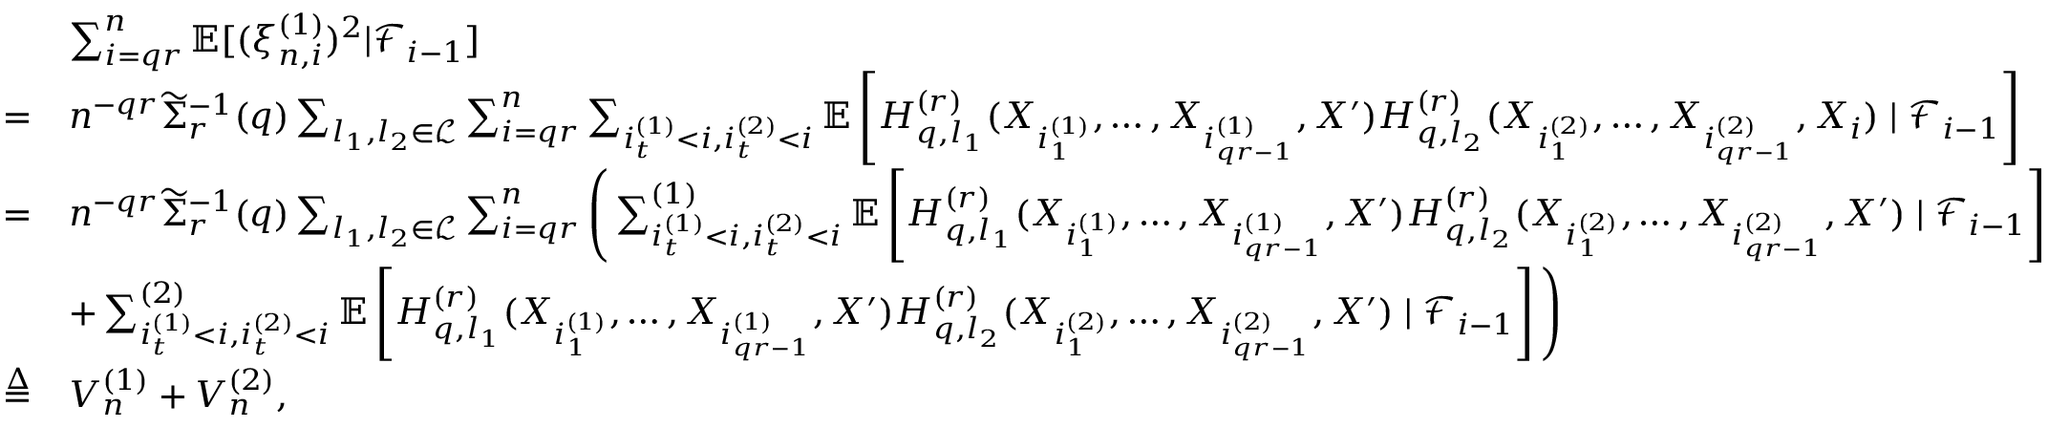<formula> <loc_0><loc_0><loc_500><loc_500>\begin{array} { r l } & { \sum _ { i = q r } ^ { n } \mathbb { E } [ ( \xi _ { n , i } ^ { ( 1 ) } ) ^ { 2 } | \mathcal { F } _ { i - 1 } ] } \\ { = } & { n ^ { - q r } \widetilde { \Sigma } _ { r } ^ { - 1 } ( q ) \sum _ { l _ { 1 } , l _ { 2 } \in \mathcal { L } } \sum _ { i = q r } ^ { n } \sum _ { i _ { t } ^ { ( 1 ) } < i , i _ { t } ^ { ( 2 ) } < i } \mathbb { E } \left [ H _ { q , l _ { 1 } } ^ { ( r ) } ( X _ { i _ { 1 } ^ { ( 1 ) } } , \dots , X _ { i _ { q r - 1 } ^ { ( 1 ) } } , X ^ { \prime } ) H _ { q , l _ { 2 } } ^ { ( r ) } ( X _ { i _ { 1 } ^ { ( 2 ) } } , \dots , X _ { i _ { q r - 1 } ^ { ( 2 ) } } , X _ { i } ) | \mathcal { F } _ { i - 1 } \right ] } \\ { = } & { n ^ { - q r } \widetilde { \Sigma } _ { r } ^ { - 1 } ( q ) \sum _ { l _ { 1 } , l _ { 2 } \in \mathcal { L } } \sum _ { i = q r } ^ { n } \left ( \sum _ { i _ { t } ^ { ( 1 ) } < i , i _ { t } ^ { ( 2 ) } < i } ^ { ( 1 ) } \mathbb { E } \left [ H _ { q , l _ { 1 } } ^ { ( r ) } ( X _ { i _ { 1 } ^ { ( 1 ) } } , \dots , X _ { i _ { q r - 1 } ^ { ( 1 ) } } , X ^ { \prime } ) H _ { q , l _ { 2 } } ^ { ( r ) } ( X _ { i _ { 1 } ^ { ( 2 ) } } , \dots , X _ { i _ { q r - 1 } ^ { ( 2 ) } } , X ^ { \prime } ) | \mathcal { F } _ { i - 1 } \right ] } \\ & { + \sum _ { i _ { t } ^ { ( 1 ) } < i , i _ { t } ^ { ( 2 ) } < i } ^ { ( 2 ) } \mathbb { E } \left [ H _ { q , l _ { 1 } } ^ { ( r ) } ( X _ { i _ { 1 } ^ { ( 1 ) } } , \dots , X _ { i _ { q r - 1 } ^ { ( 1 ) } } , X ^ { \prime } ) H _ { q , l _ { 2 } } ^ { ( r ) } ( X _ { i _ { 1 } ^ { ( 2 ) } } , \dots , X _ { i _ { q r - 1 } ^ { ( 2 ) } } , X ^ { \prime } ) | \mathcal { F } _ { i - 1 } \right ] \right ) } \\ { \overset { \Delta } { = } } & { V _ { n } ^ { ( 1 ) } + V _ { n } ^ { ( 2 ) } , } \end{array}</formula> 